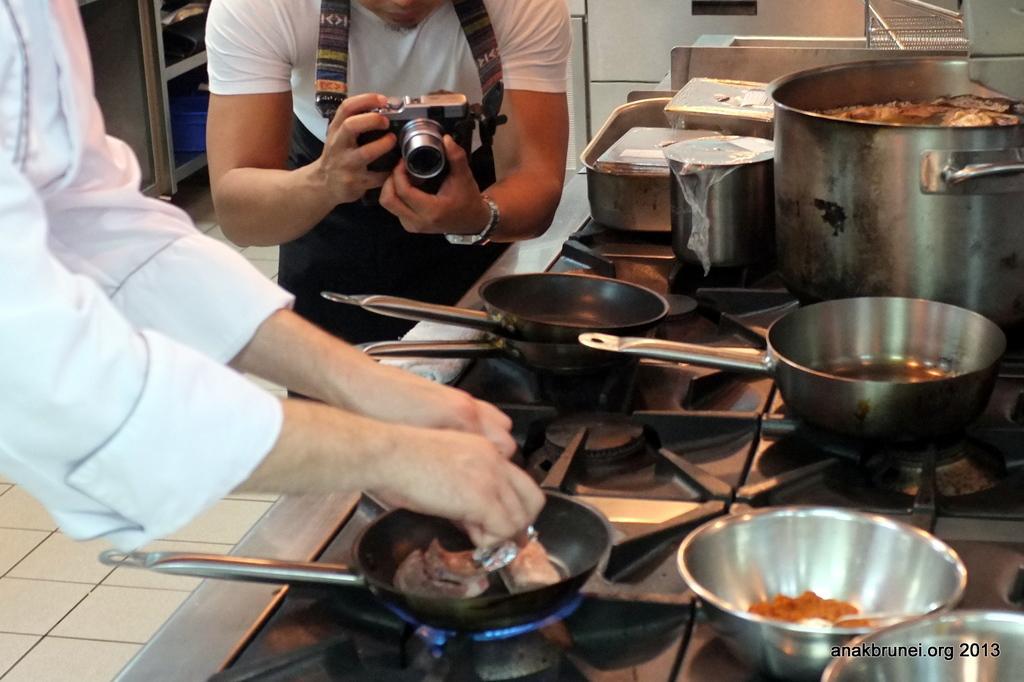Can you describe this image briefly? The picture is taken in a kitchen. In the foreground of the picture there are pans, stove, flame, food items, vessels and other objects. On the left there are two persons. In the center there is a person holding camera. In the background there are closet and other kitchen utensils. 